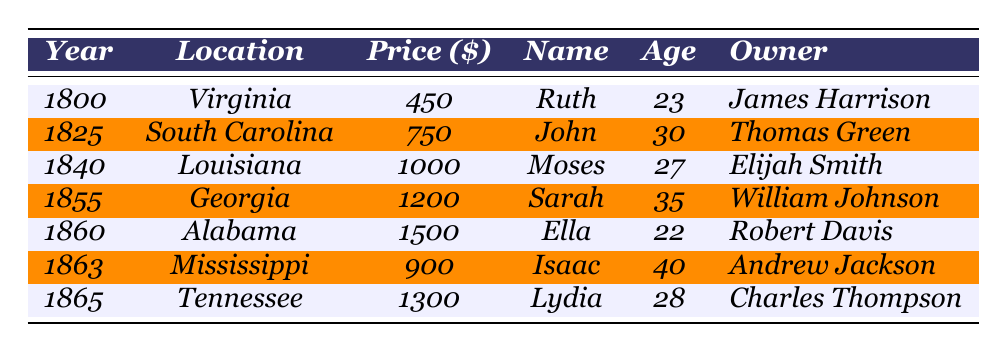What was the highest sale price recorded in the table? The highest sale price can be found by scanning through the "Price" column. The prices listed are 450, 750, 1000, 1200, 1500, 900, and 1300. The highest among these is 1500.
Answer: 1500 Who was the owner of the slave sold for 1200 dollars? To find the owner of the slave sold for 1200 dollars, I look for the row with that sale price. The entry with a sale price of 1200 corresponds to Sarah, and her owner is listed as William Johnson.
Answer: William Johnson In which year was a slave named Isaac sold, and what was his age at that time? The table lists that Isaac was sold in the year 1863, and his age at the time of sale is 40. This information is found by locating Isaac's entry in the table.
Answer: 1863, 40 What is the average sale price of the slaves documented in the table? The sale prices are 450, 750, 1000, 1200, 1500, 900, and 1300. First, sum these values: 450 + 750 + 1000 + 1200 + 1500 + 900 + 1300 = 8100. There are 7 averages of these sale prices, so: 8100 / 7 = 1157.14 (approximately).
Answer: 1157.14 Is there a slave named Ruth who was sold before 1830? Checking the table, Ruth was sold in 1800, which is before the year 1830. Therefore, this statement is true.
Answer: Yes What was the age difference between the youngest and oldest enslaved individuals in the table? The ages listed are 23, 30, 27, 35, 22, 40, and 28. The youngest is 22 (Ella), and the oldest is 40 (Isaac). The age difference is calculated by subtracting the youngest age from the oldest age: 40 - 22 = 18.
Answer: 18 Which location hosted the most expensive slave sale, and what was the name of the slave? By reviewing the "Price" column, the most expensive sale is 1500, which corresponds to Alabama. The name of the slave sold for this price is Ella.
Answer: Alabama, Ella If the total sale prices for the years 1825 and 1865 are combined, what is that total? The sale price for 1825 is 750, and for 1865 it is 1300. Adding these two prices together: 750 + 1300 = 2050.
Answer: 2050 Which slave sale occurred in Louisiana, and how much was it sold for? Looking in the table, the entry for Louisiana indicates that Moses was the slave sold there for a price of 1000 dollars.
Answer: Moses, 1000 How many unique owners can be identified from the table? The owners listed are James Harrison, Thomas Green, Elijah Smith, William Johnson, Robert Davis, Andrew Jackson, and Charles Thompson. Counting these unique individuals gives a total of 7 owners.
Answer: 7 